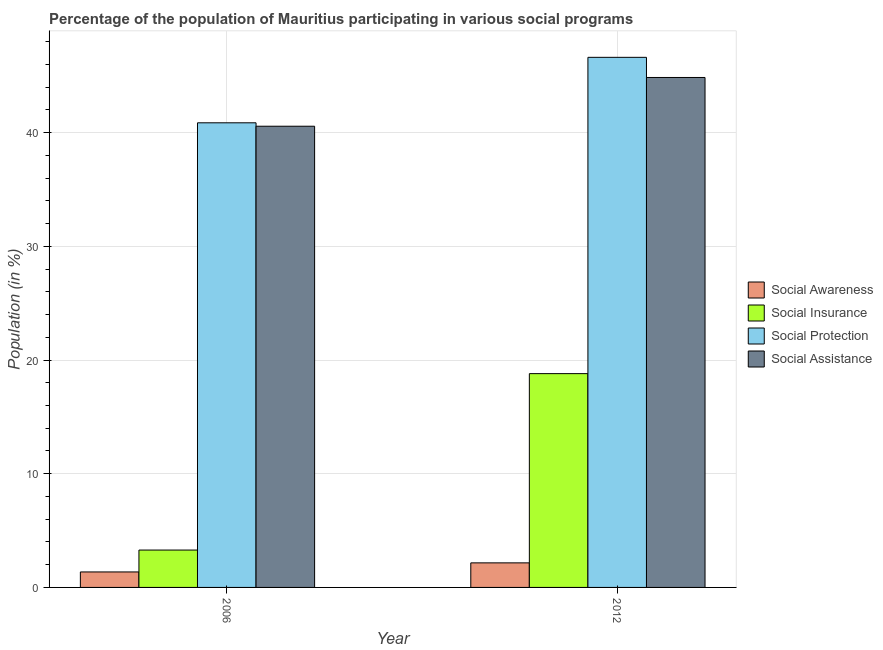How many different coloured bars are there?
Your response must be concise. 4. Are the number of bars per tick equal to the number of legend labels?
Provide a succinct answer. Yes. What is the label of the 2nd group of bars from the left?
Ensure brevity in your answer.  2012. In how many cases, is the number of bars for a given year not equal to the number of legend labels?
Offer a very short reply. 0. What is the participation of population in social protection programs in 2006?
Keep it short and to the point. 40.87. Across all years, what is the maximum participation of population in social awareness programs?
Keep it short and to the point. 2.16. Across all years, what is the minimum participation of population in social awareness programs?
Your answer should be compact. 1.36. What is the total participation of population in social assistance programs in the graph?
Provide a short and direct response. 85.42. What is the difference between the participation of population in social insurance programs in 2006 and that in 2012?
Your answer should be compact. -15.52. What is the difference between the participation of population in social insurance programs in 2012 and the participation of population in social awareness programs in 2006?
Offer a very short reply. 15.52. What is the average participation of population in social protection programs per year?
Give a very brief answer. 43.75. What is the ratio of the participation of population in social protection programs in 2006 to that in 2012?
Offer a very short reply. 0.88. Is the participation of population in social assistance programs in 2006 less than that in 2012?
Your response must be concise. Yes. What does the 4th bar from the left in 2012 represents?
Your response must be concise. Social Assistance. What does the 4th bar from the right in 2012 represents?
Keep it short and to the point. Social Awareness. Is it the case that in every year, the sum of the participation of population in social awareness programs and participation of population in social insurance programs is greater than the participation of population in social protection programs?
Give a very brief answer. No. How many bars are there?
Ensure brevity in your answer.  8. How many years are there in the graph?
Offer a terse response. 2. Does the graph contain grids?
Your answer should be compact. Yes. How are the legend labels stacked?
Keep it short and to the point. Vertical. What is the title of the graph?
Keep it short and to the point. Percentage of the population of Mauritius participating in various social programs . Does "Portugal" appear as one of the legend labels in the graph?
Ensure brevity in your answer.  No. What is the Population (in %) of Social Awareness in 2006?
Keep it short and to the point. 1.36. What is the Population (in %) of Social Insurance in 2006?
Offer a very short reply. 3.29. What is the Population (in %) of Social Protection in 2006?
Ensure brevity in your answer.  40.87. What is the Population (in %) of Social Assistance in 2006?
Provide a short and direct response. 40.57. What is the Population (in %) of Social Awareness in 2012?
Give a very brief answer. 2.16. What is the Population (in %) of Social Insurance in 2012?
Provide a short and direct response. 18.8. What is the Population (in %) in Social Protection in 2012?
Your answer should be very brief. 46.63. What is the Population (in %) of Social Assistance in 2012?
Ensure brevity in your answer.  44.85. Across all years, what is the maximum Population (in %) of Social Awareness?
Make the answer very short. 2.16. Across all years, what is the maximum Population (in %) in Social Insurance?
Provide a succinct answer. 18.8. Across all years, what is the maximum Population (in %) of Social Protection?
Give a very brief answer. 46.63. Across all years, what is the maximum Population (in %) in Social Assistance?
Make the answer very short. 44.85. Across all years, what is the minimum Population (in %) of Social Awareness?
Offer a terse response. 1.36. Across all years, what is the minimum Population (in %) of Social Insurance?
Offer a very short reply. 3.29. Across all years, what is the minimum Population (in %) of Social Protection?
Give a very brief answer. 40.87. Across all years, what is the minimum Population (in %) in Social Assistance?
Provide a succinct answer. 40.57. What is the total Population (in %) in Social Awareness in the graph?
Keep it short and to the point. 3.52. What is the total Population (in %) of Social Insurance in the graph?
Your answer should be compact. 22.09. What is the total Population (in %) in Social Protection in the graph?
Your answer should be very brief. 87.49. What is the total Population (in %) in Social Assistance in the graph?
Provide a short and direct response. 85.42. What is the difference between the Population (in %) of Social Awareness in 2006 and that in 2012?
Your answer should be compact. -0.8. What is the difference between the Population (in %) in Social Insurance in 2006 and that in 2012?
Your response must be concise. -15.52. What is the difference between the Population (in %) of Social Protection in 2006 and that in 2012?
Offer a very short reply. -5.76. What is the difference between the Population (in %) of Social Assistance in 2006 and that in 2012?
Give a very brief answer. -4.29. What is the difference between the Population (in %) of Social Awareness in 2006 and the Population (in %) of Social Insurance in 2012?
Provide a short and direct response. -17.44. What is the difference between the Population (in %) of Social Awareness in 2006 and the Population (in %) of Social Protection in 2012?
Provide a succinct answer. -45.26. What is the difference between the Population (in %) of Social Awareness in 2006 and the Population (in %) of Social Assistance in 2012?
Offer a terse response. -43.49. What is the difference between the Population (in %) of Social Insurance in 2006 and the Population (in %) of Social Protection in 2012?
Provide a succinct answer. -43.34. What is the difference between the Population (in %) in Social Insurance in 2006 and the Population (in %) in Social Assistance in 2012?
Give a very brief answer. -41.57. What is the difference between the Population (in %) in Social Protection in 2006 and the Population (in %) in Social Assistance in 2012?
Keep it short and to the point. -3.99. What is the average Population (in %) of Social Awareness per year?
Offer a terse response. 1.76. What is the average Population (in %) of Social Insurance per year?
Give a very brief answer. 11.05. What is the average Population (in %) in Social Protection per year?
Provide a succinct answer. 43.75. What is the average Population (in %) in Social Assistance per year?
Provide a succinct answer. 42.71. In the year 2006, what is the difference between the Population (in %) in Social Awareness and Population (in %) in Social Insurance?
Keep it short and to the point. -1.92. In the year 2006, what is the difference between the Population (in %) in Social Awareness and Population (in %) in Social Protection?
Give a very brief answer. -39.51. In the year 2006, what is the difference between the Population (in %) in Social Awareness and Population (in %) in Social Assistance?
Keep it short and to the point. -39.2. In the year 2006, what is the difference between the Population (in %) in Social Insurance and Population (in %) in Social Protection?
Give a very brief answer. -37.58. In the year 2006, what is the difference between the Population (in %) of Social Insurance and Population (in %) of Social Assistance?
Provide a short and direct response. -37.28. In the year 2006, what is the difference between the Population (in %) of Social Protection and Population (in %) of Social Assistance?
Give a very brief answer. 0.3. In the year 2012, what is the difference between the Population (in %) of Social Awareness and Population (in %) of Social Insurance?
Your answer should be very brief. -16.64. In the year 2012, what is the difference between the Population (in %) of Social Awareness and Population (in %) of Social Protection?
Your answer should be compact. -44.47. In the year 2012, what is the difference between the Population (in %) in Social Awareness and Population (in %) in Social Assistance?
Your answer should be very brief. -42.69. In the year 2012, what is the difference between the Population (in %) of Social Insurance and Population (in %) of Social Protection?
Provide a short and direct response. -27.82. In the year 2012, what is the difference between the Population (in %) in Social Insurance and Population (in %) in Social Assistance?
Provide a succinct answer. -26.05. In the year 2012, what is the difference between the Population (in %) of Social Protection and Population (in %) of Social Assistance?
Keep it short and to the point. 1.77. What is the ratio of the Population (in %) of Social Awareness in 2006 to that in 2012?
Provide a short and direct response. 0.63. What is the ratio of the Population (in %) of Social Insurance in 2006 to that in 2012?
Your response must be concise. 0.17. What is the ratio of the Population (in %) in Social Protection in 2006 to that in 2012?
Provide a short and direct response. 0.88. What is the ratio of the Population (in %) in Social Assistance in 2006 to that in 2012?
Make the answer very short. 0.9. What is the difference between the highest and the second highest Population (in %) in Social Awareness?
Provide a succinct answer. 0.8. What is the difference between the highest and the second highest Population (in %) in Social Insurance?
Provide a short and direct response. 15.52. What is the difference between the highest and the second highest Population (in %) in Social Protection?
Provide a short and direct response. 5.76. What is the difference between the highest and the second highest Population (in %) in Social Assistance?
Provide a short and direct response. 4.29. What is the difference between the highest and the lowest Population (in %) in Social Awareness?
Your answer should be very brief. 0.8. What is the difference between the highest and the lowest Population (in %) in Social Insurance?
Offer a terse response. 15.52. What is the difference between the highest and the lowest Population (in %) of Social Protection?
Your answer should be compact. 5.76. What is the difference between the highest and the lowest Population (in %) in Social Assistance?
Keep it short and to the point. 4.29. 